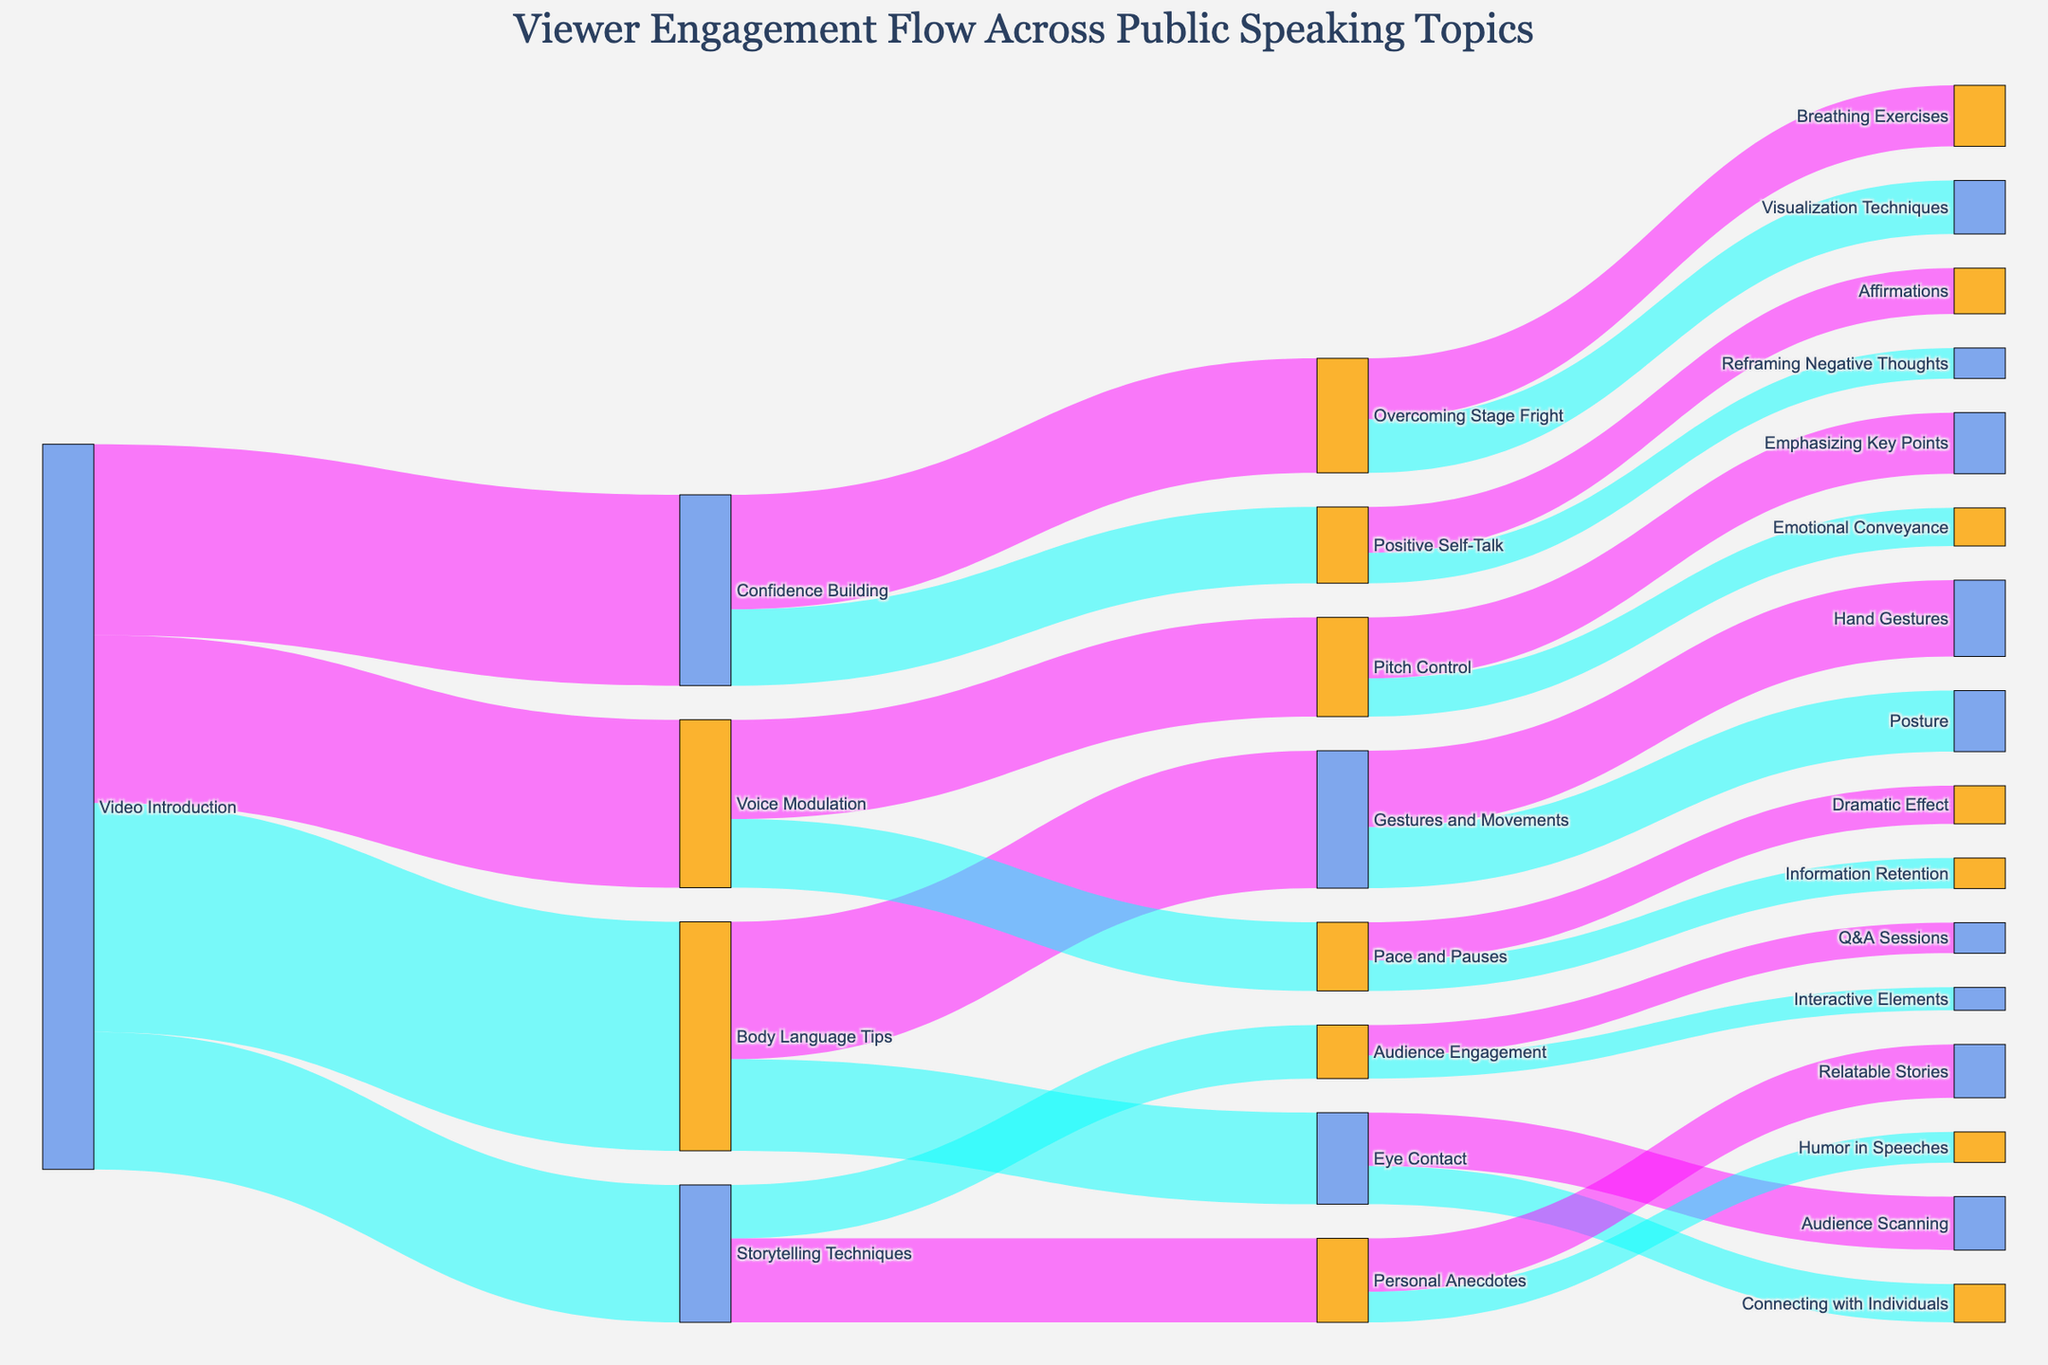What is the title of the Sankey diagram? The title is the main textual element at the top center of the diagram that describes what the diagram is about. It summarizes the main focus of the visual representation.
Answer: Viewer Engagement Flow Across Public Speaking Topics Which topic has the highest number of viewers moving from the Video Introduction? To find the topic with the highest number of viewers from Video Introduction, look for the link with the largest value originating from Video Introduction.
Answer: Body Language Tips How many topics did viewers move to directly from Confidence Building? To determine this, count the number of direct outgoing links from the Confidence Building node to other topics.
Answer: 2 What is the sum of viewers who moved to Gestures and Movements and Eye Contact from Body Language Tips? Add the values of viewers moving from Body Language Tips to Gestures and Movements and Eye Contact. (1800 + 1200)
Answer: 3000 Which subtopic under Voice Modulation has fewer viewers: Pitch Control or Pace and Pauses? Compare the values of viewers moving to Pitch Control and Pace and Pauses from Voice Modulation.
Answer: Pace and Pauses What is the total viewer count moving from Video Introduction to all other topics? Sum up the values of all outgoing links from Video Introduction. (2500 + 3000 + 2200 + 1800)
Answer: 9500 How does the number of viewers moving to Overcoming Stage Fright from Confidence Building compare to those moving to Personal Anecdotes from Storytelling Techniques? Compare the values for the outgoing links to Overcoming Stage Fright from Confidence Building and to Personal Anecdotes from Storytelling Techniques.
Answer: Higher for Overcoming Stage Fright What is the viewer split between Breathing Exercises and Visualization Techniques from Overcoming Stage Fright? Identify the number of viewers moving to each category from Overcoming Stage Fright (800 to Breathing Exercises, 700 to Visualization Techniques) and state their difference.
Answer: Breathing Exercises receives more by 100 viewers 